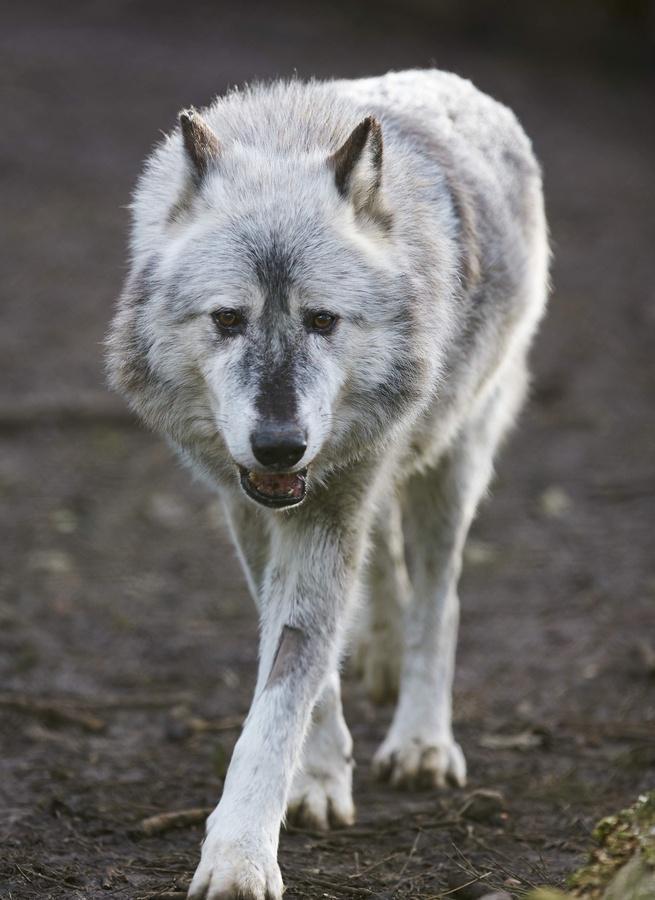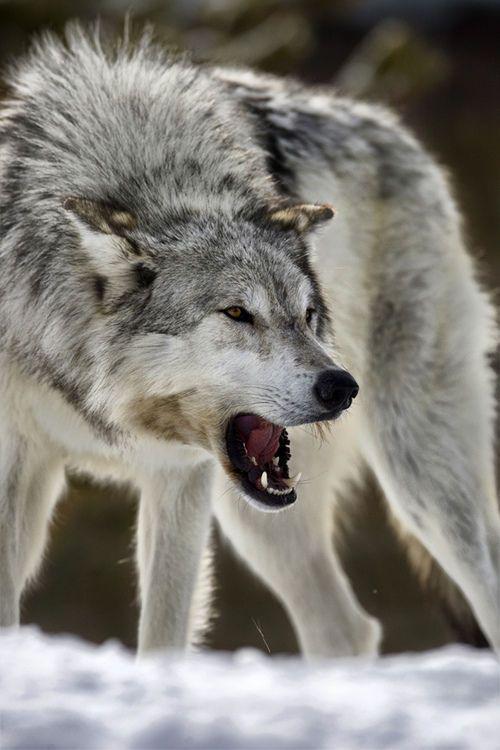The first image is the image on the left, the second image is the image on the right. Given the left and right images, does the statement "The animal in the image on the right has an open mouth." hold true? Answer yes or no. Yes. 